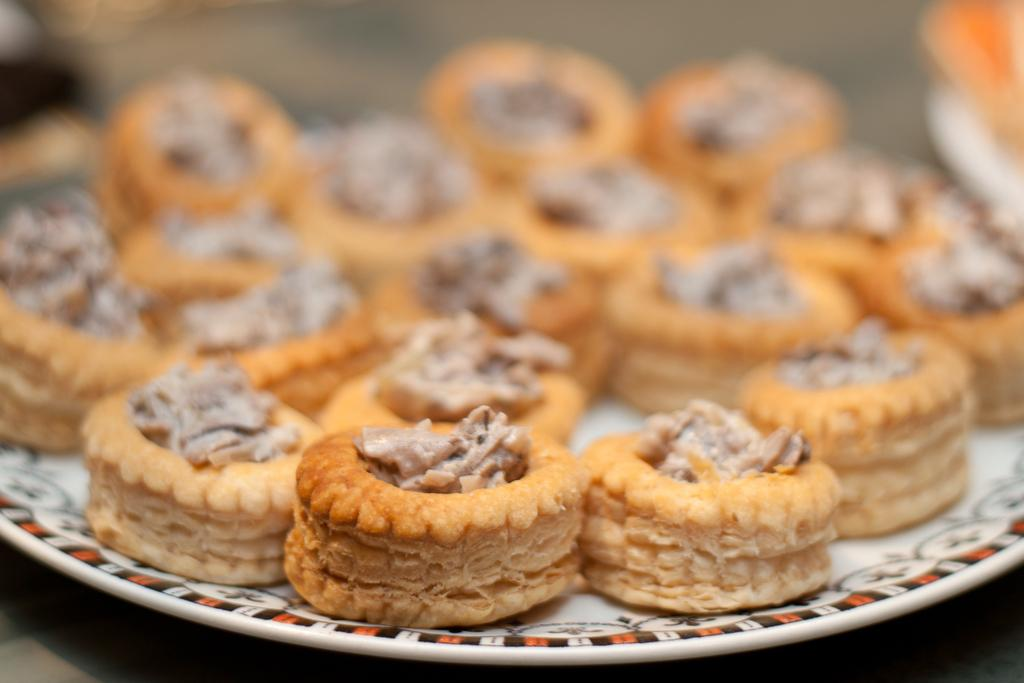What is on the plate in the image? There are food items on a plate in the image. Can you describe the background of the image? The background of the image is blurred. How many eyes can be seen on the plate in the image? There are no eyes present on the plate in the image. What type of toys are scattered around the plate in the image? There are no toys present in the image. 